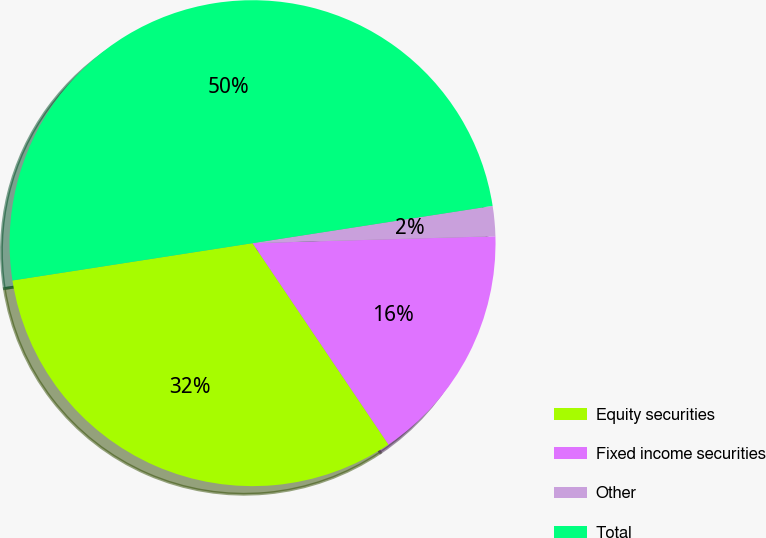Convert chart to OTSL. <chart><loc_0><loc_0><loc_500><loc_500><pie_chart><fcel>Equity securities<fcel>Fixed income securities<fcel>Other<fcel>Total<nl><fcel>32.0%<fcel>16.0%<fcel>2.0%<fcel>50.0%<nl></chart> 